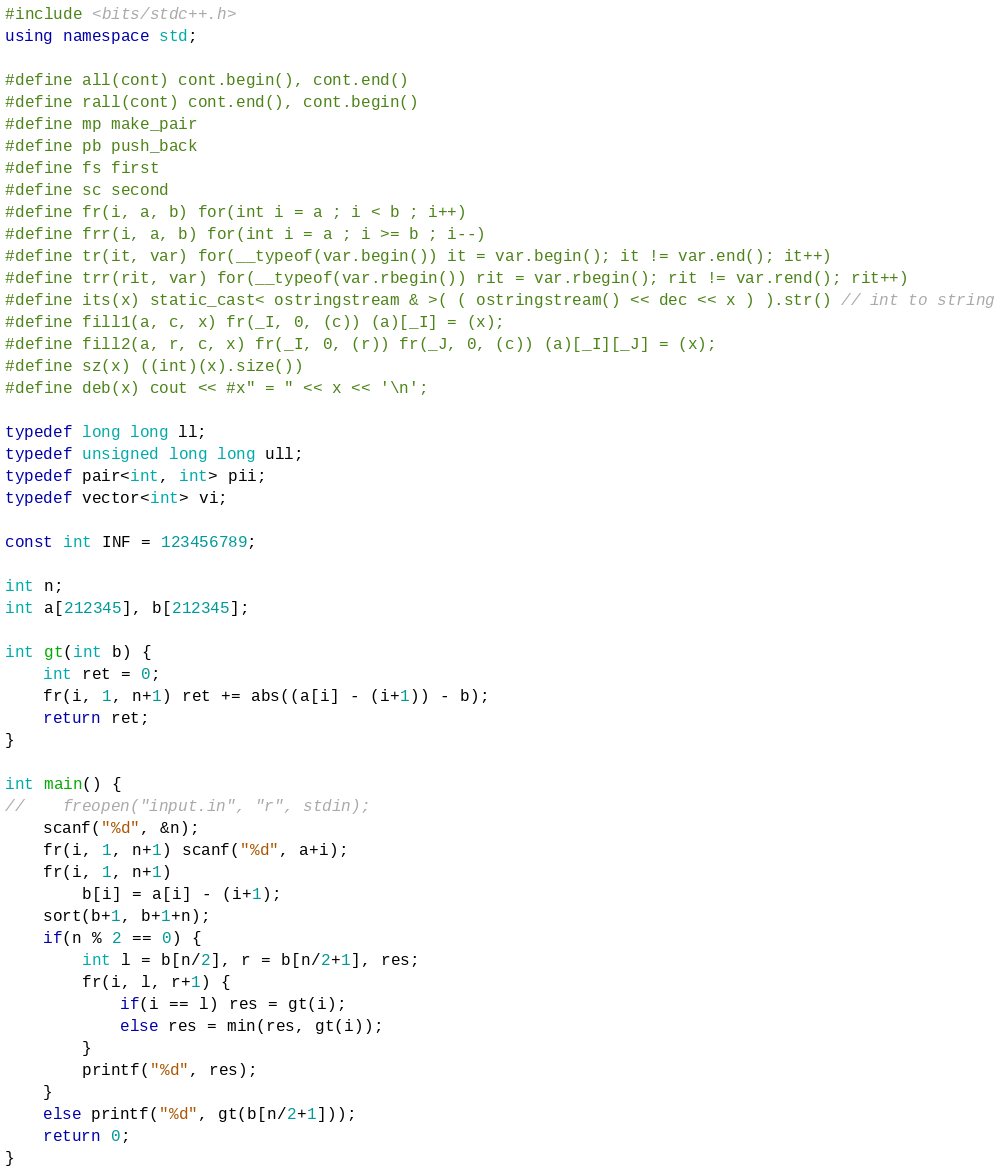<code> <loc_0><loc_0><loc_500><loc_500><_C++_>#include <bits/stdc++.h>
using namespace std;

#define all(cont) cont.begin(), cont.end()
#define rall(cont) cont.end(), cont.begin()
#define mp make_pair
#define pb push_back
#define fs first
#define sc second
#define fr(i, a, b) for(int i = a ; i < b ; i++)
#define frr(i, a, b) for(int i = a ; i >= b ; i--)
#define tr(it, var) for(__typeof(var.begin()) it = var.begin(); it != var.end(); it++)
#define trr(rit, var) for(__typeof(var.rbegin()) rit = var.rbegin(); rit != var.rend(); rit++)
#define its(x) static_cast< ostringstream & >( ( ostringstream() << dec << x ) ).str() // int to string
#define fill1(a, c, x) fr(_I, 0, (c)) (a)[_I] = (x);
#define fill2(a, r, c, x) fr(_I, 0, (r)) fr(_J, 0, (c)) (a)[_I][_J] = (x);
#define sz(x) ((int)(x).size())
#define deb(x) cout << #x" = " << x << '\n';

typedef long long ll;
typedef unsigned long long ull;
typedef pair<int, int> pii;
typedef vector<int> vi;

const int INF = 123456789;

int n;
int a[212345], b[212345];

int gt(int b) {
	int ret = 0;
	fr(i, 1, n+1) ret += abs((a[i] - (i+1)) - b);
	return ret;
}

int main() {
//    freopen("input.in", "r", stdin);
	scanf("%d", &n);
	fr(i, 1, n+1) scanf("%d", a+i);
	fr(i, 1, n+1) 
		b[i] = a[i] - (i+1);
	sort(b+1, b+1+n);
	if(n % 2 == 0) {
		int l = b[n/2], r = b[n/2+1], res;
		fr(i, l, r+1) {
			if(i == l) res = gt(i);
			else res = min(res, gt(i));
		}
		printf("%d", res);
	}
	else printf("%d", gt(b[n/2+1]));
	return 0;
}</code> 